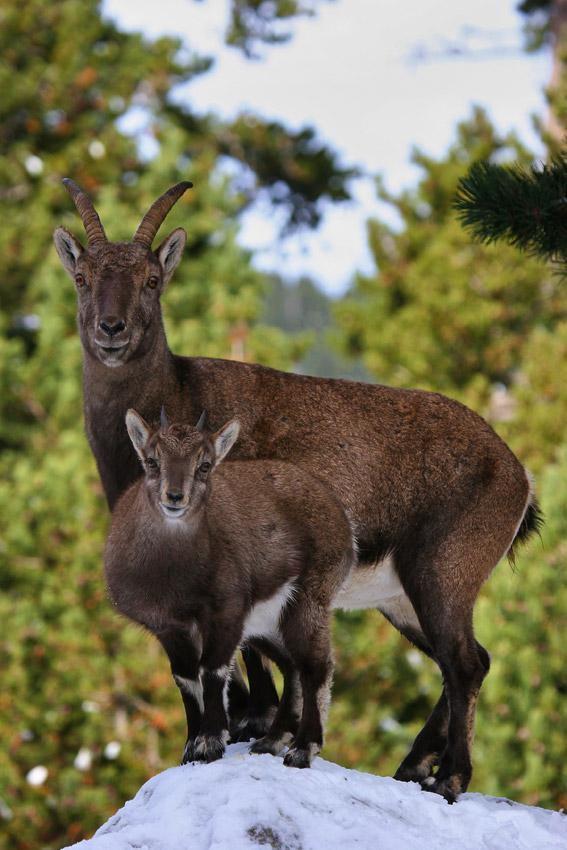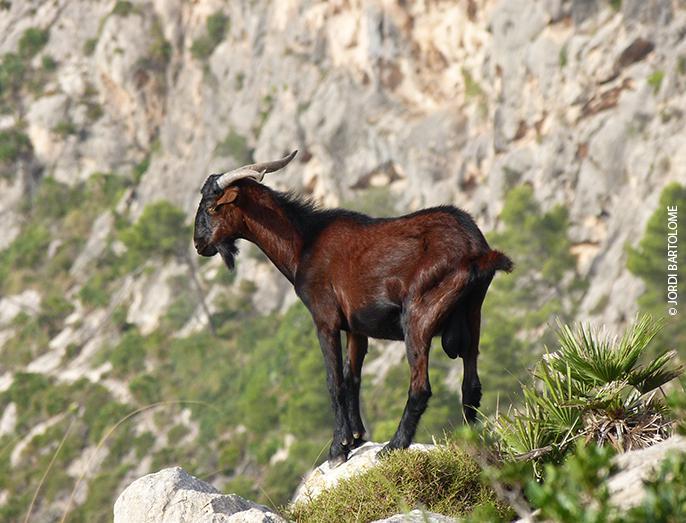The first image is the image on the left, the second image is the image on the right. For the images displayed, is the sentence "There are more than two animals." factually correct? Answer yes or no. Yes. 